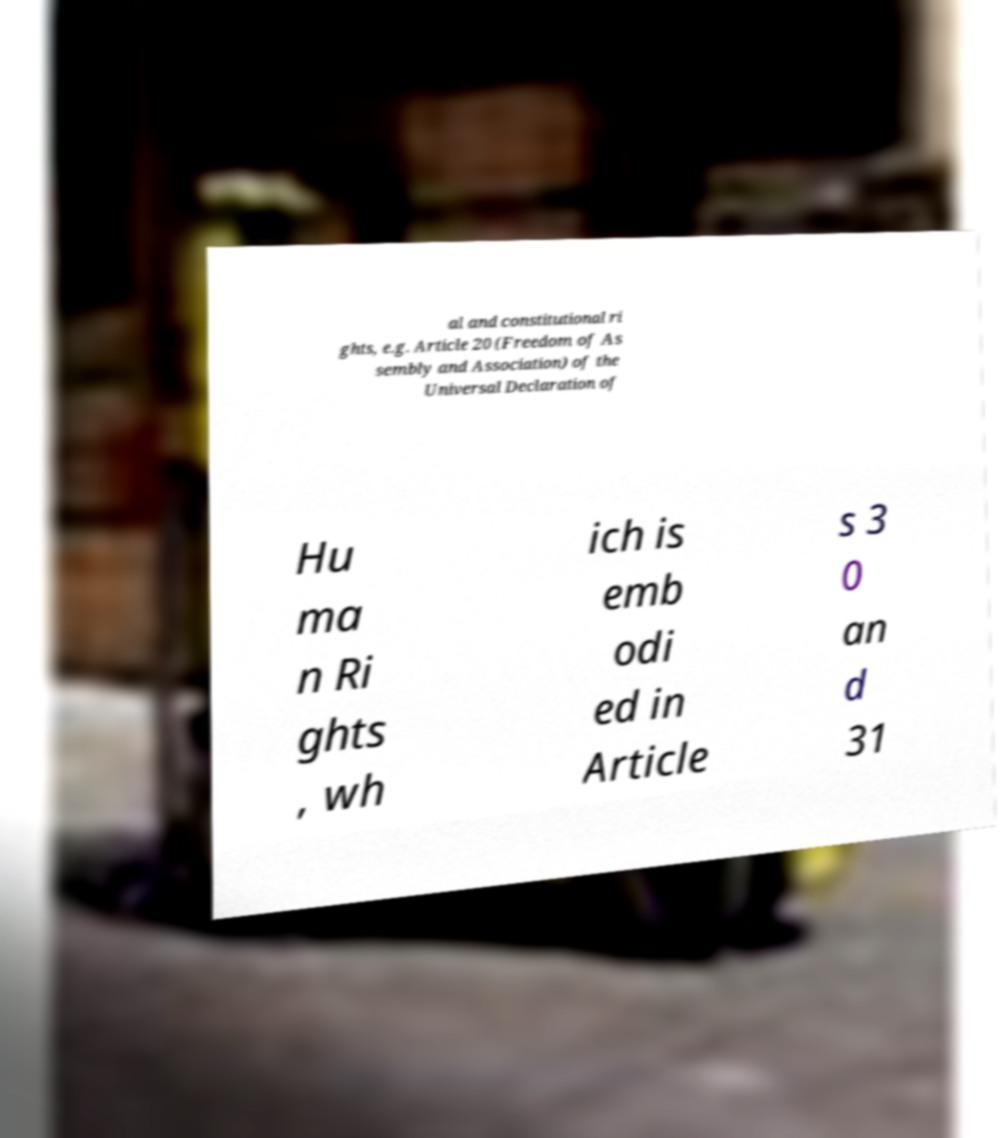Please identify and transcribe the text found in this image. al and constitutional ri ghts, e.g. Article 20 (Freedom of As sembly and Association) of the Universal Declaration of Hu ma n Ri ghts , wh ich is emb odi ed in Article s 3 0 an d 31 